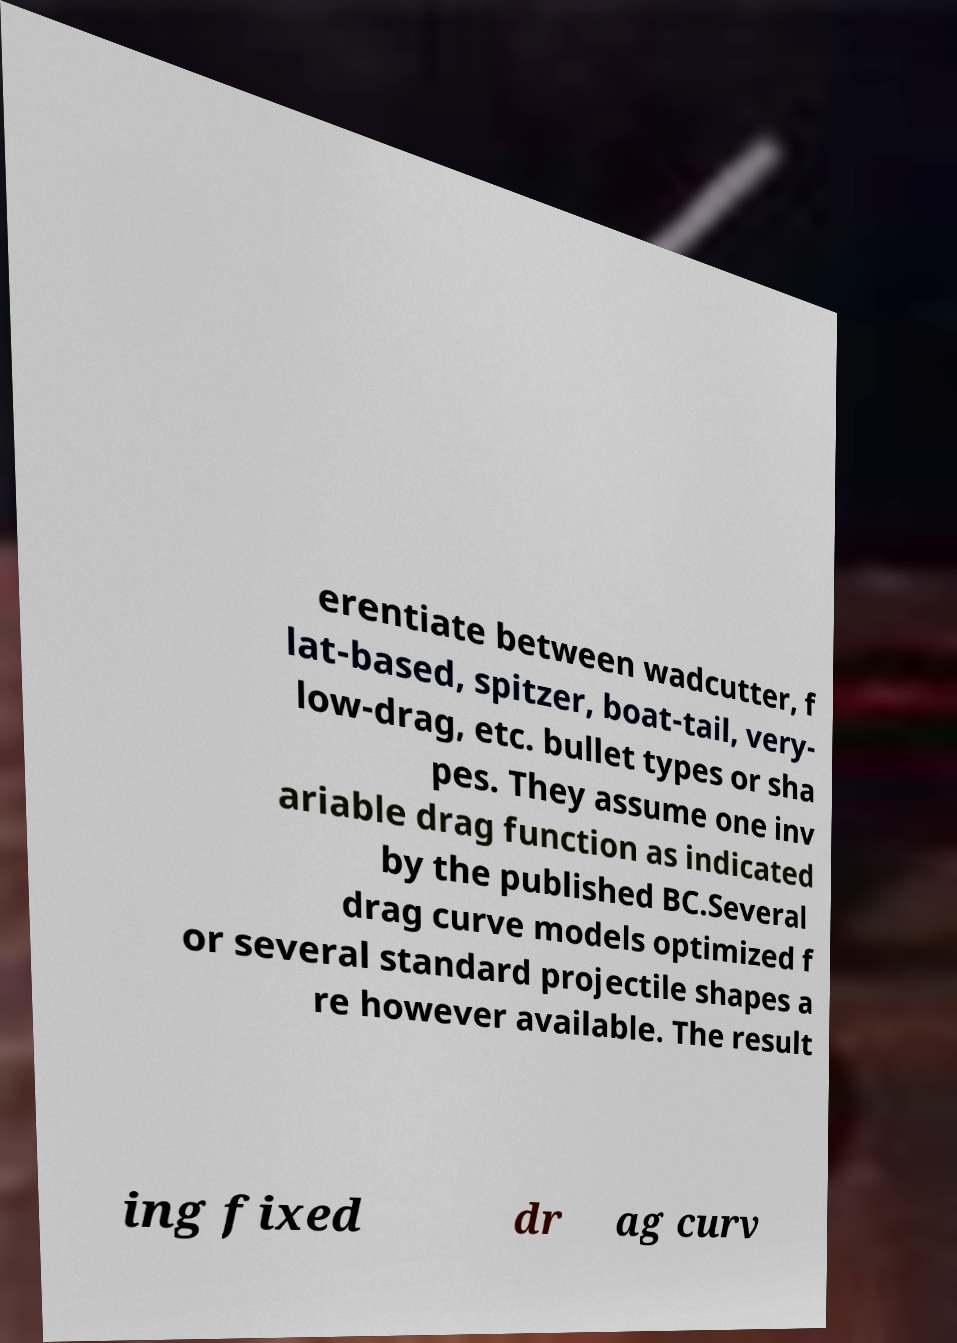Could you assist in decoding the text presented in this image and type it out clearly? erentiate between wadcutter, f lat-based, spitzer, boat-tail, very- low-drag, etc. bullet types or sha pes. They assume one inv ariable drag function as indicated by the published BC.Several drag curve models optimized f or several standard projectile shapes a re however available. The result ing fixed dr ag curv 